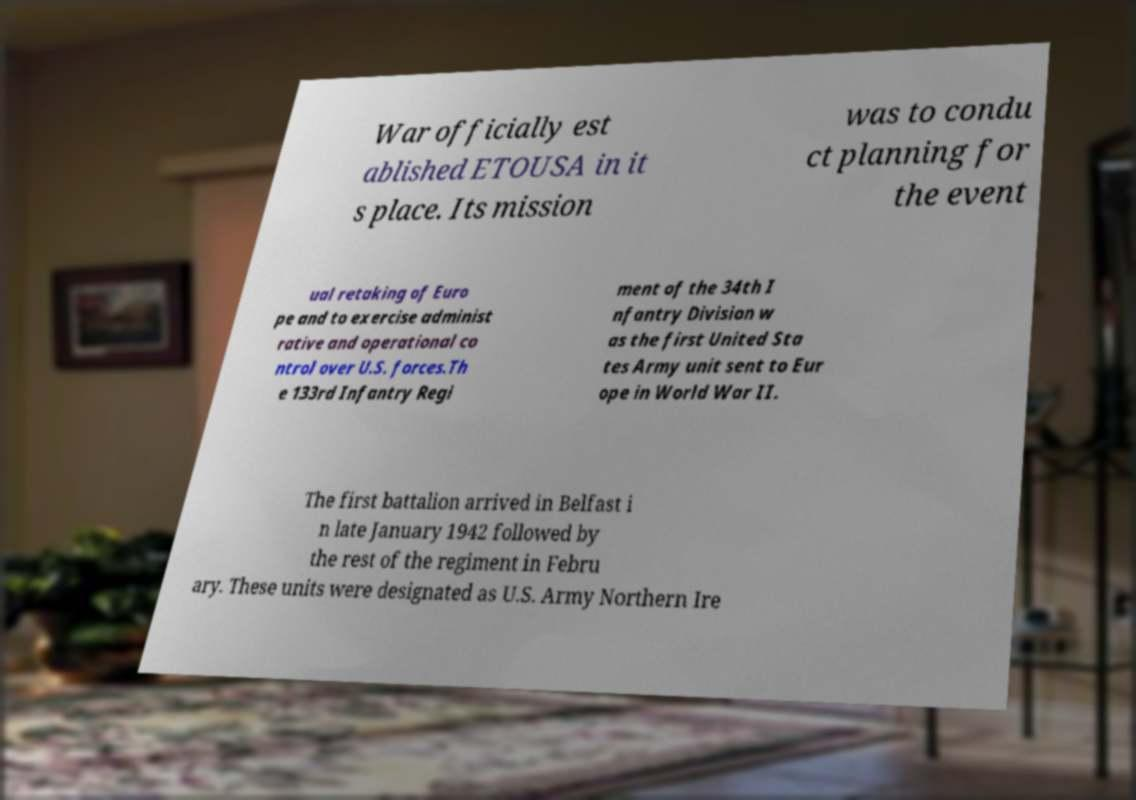Can you accurately transcribe the text from the provided image for me? War officially est ablished ETOUSA in it s place. Its mission was to condu ct planning for the event ual retaking of Euro pe and to exercise administ rative and operational co ntrol over U.S. forces.Th e 133rd Infantry Regi ment of the 34th I nfantry Division w as the first United Sta tes Army unit sent to Eur ope in World War II. The first battalion arrived in Belfast i n late January 1942 followed by the rest of the regiment in Febru ary. These units were designated as U.S. Army Northern Ire 